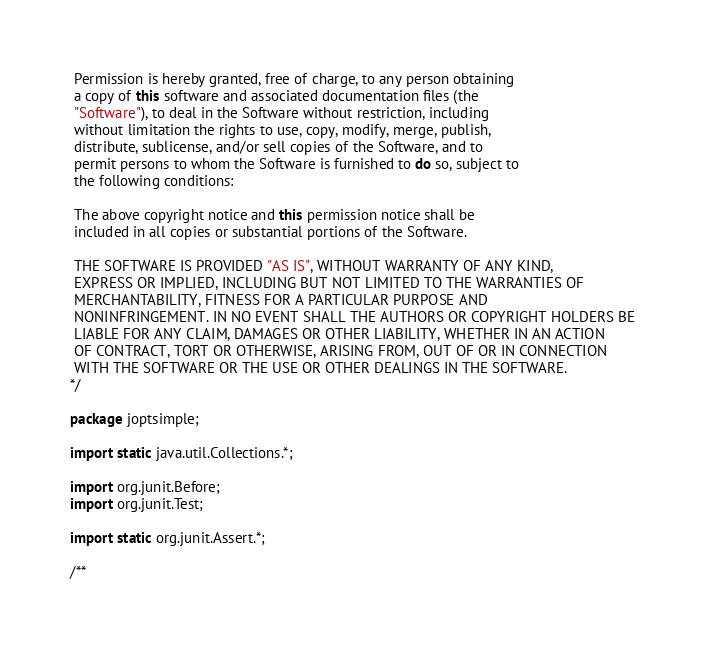Convert code to text. <code><loc_0><loc_0><loc_500><loc_500><_Java_> Permission is hereby granted, free of charge, to any person obtaining
 a copy of this software and associated documentation files (the
 "Software"), to deal in the Software without restriction, including
 without limitation the rights to use, copy, modify, merge, publish,
 distribute, sublicense, and/or sell copies of the Software, and to
 permit persons to whom the Software is furnished to do so, subject to
 the following conditions:

 The above copyright notice and this permission notice shall be
 included in all copies or substantial portions of the Software.

 THE SOFTWARE IS PROVIDED "AS IS", WITHOUT WARRANTY OF ANY KIND,
 EXPRESS OR IMPLIED, INCLUDING BUT NOT LIMITED TO THE WARRANTIES OF
 MERCHANTABILITY, FITNESS FOR A PARTICULAR PURPOSE AND
 NONINFRINGEMENT. IN NO EVENT SHALL THE AUTHORS OR COPYRIGHT HOLDERS BE
 LIABLE FOR ANY CLAIM, DAMAGES OR OTHER LIABILITY, WHETHER IN AN ACTION
 OF CONTRACT, TORT OR OTHERWISE, ARISING FROM, OUT OF OR IN CONNECTION
 WITH THE SOFTWARE OR THE USE OR OTHER DEALINGS IN THE SOFTWARE.
*/

package joptsimple;

import static java.util.Collections.*;

import org.junit.Before;
import org.junit.Test;

import static org.junit.Assert.*;

/**</code> 